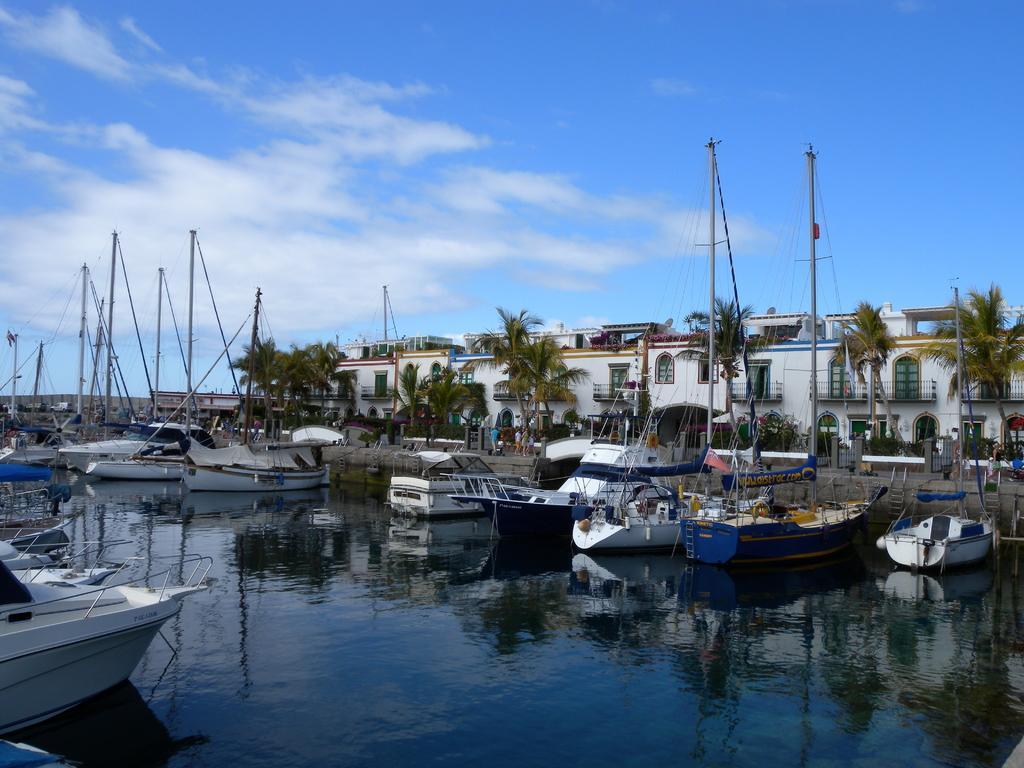Could you give a brief overview of what you see in this image? In this picture we can see boats on water and in the background we can see buildings,trees,persons,sky. 